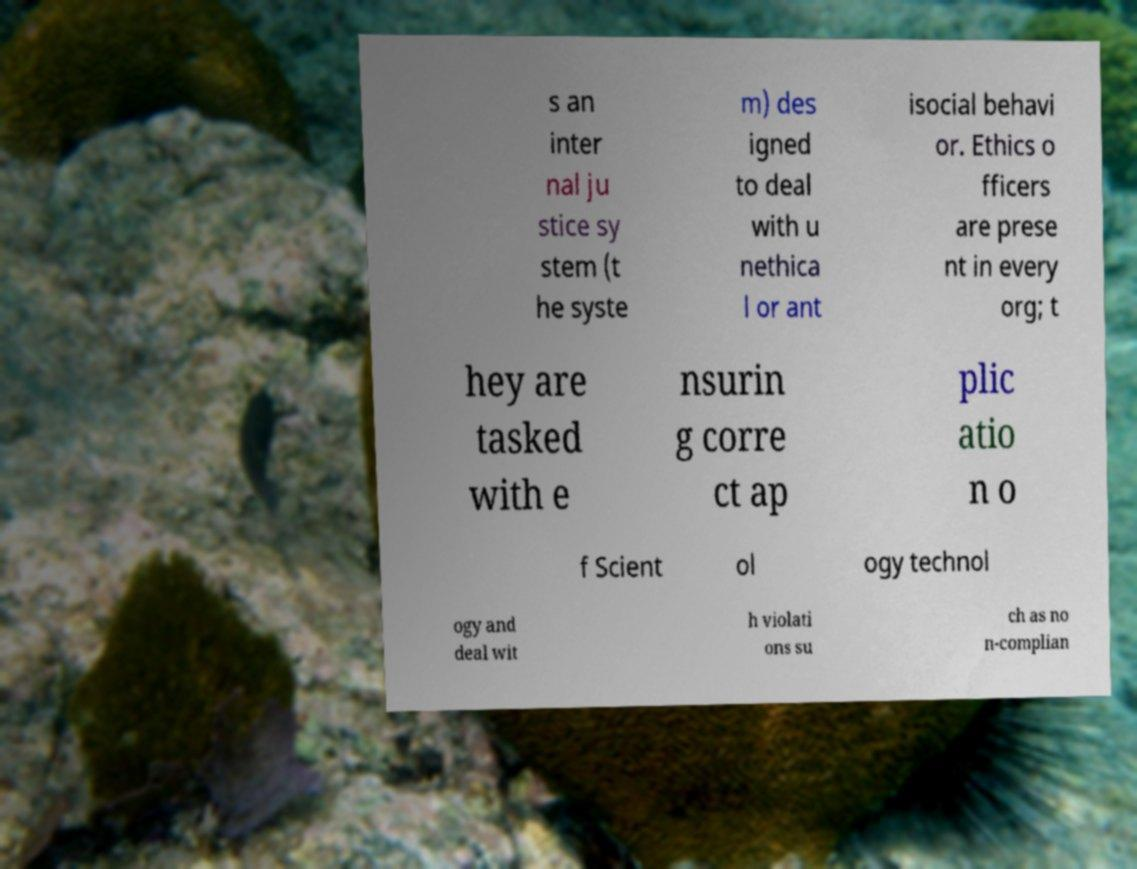I need the written content from this picture converted into text. Can you do that? s an inter nal ju stice sy stem (t he syste m) des igned to deal with u nethica l or ant isocial behavi or. Ethics o fficers are prese nt in every org; t hey are tasked with e nsurin g corre ct ap plic atio n o f Scient ol ogy technol ogy and deal wit h violati ons su ch as no n-complian 